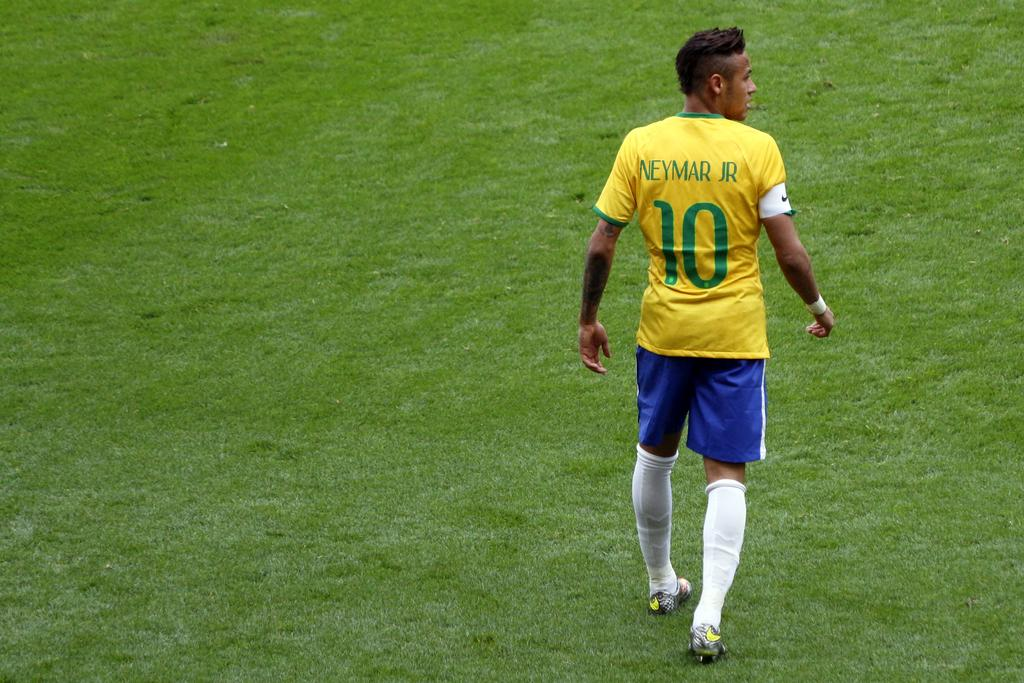<image>
Render a clear and concise summary of the photo. a soccer player wearing a red jersey that said 'neymar jr 10' on the back 